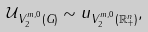<formula> <loc_0><loc_0><loc_500><loc_500>\| { \mathcal { U } } \| _ { V _ { 2 } ^ { m , 0 } ( G ) } \sim \| u \| _ { V _ { 2 } ^ { m , 0 } ( \mathbb { R } ^ { n } _ { + } ) } ,</formula> 